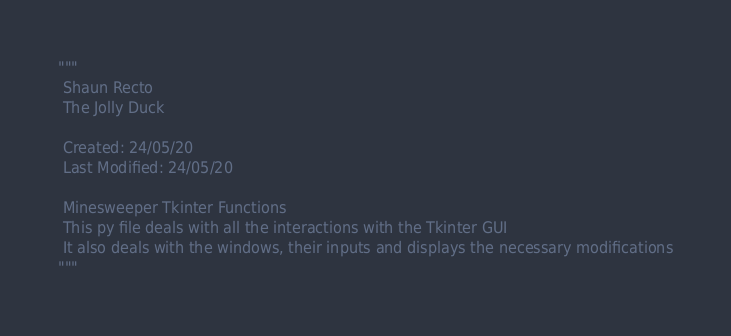<code> <loc_0><loc_0><loc_500><loc_500><_Python_>"""
 Shaun Recto
 The Jolly Duck

 Created: 24/05/20
 Last Modified: 24/05/20

 Minesweeper Tkinter Functions
 This py file deals with all the interactions with the Tkinter GUI
 It also deals with the windows, their inputs and displays the necessary modifications
"""</code> 